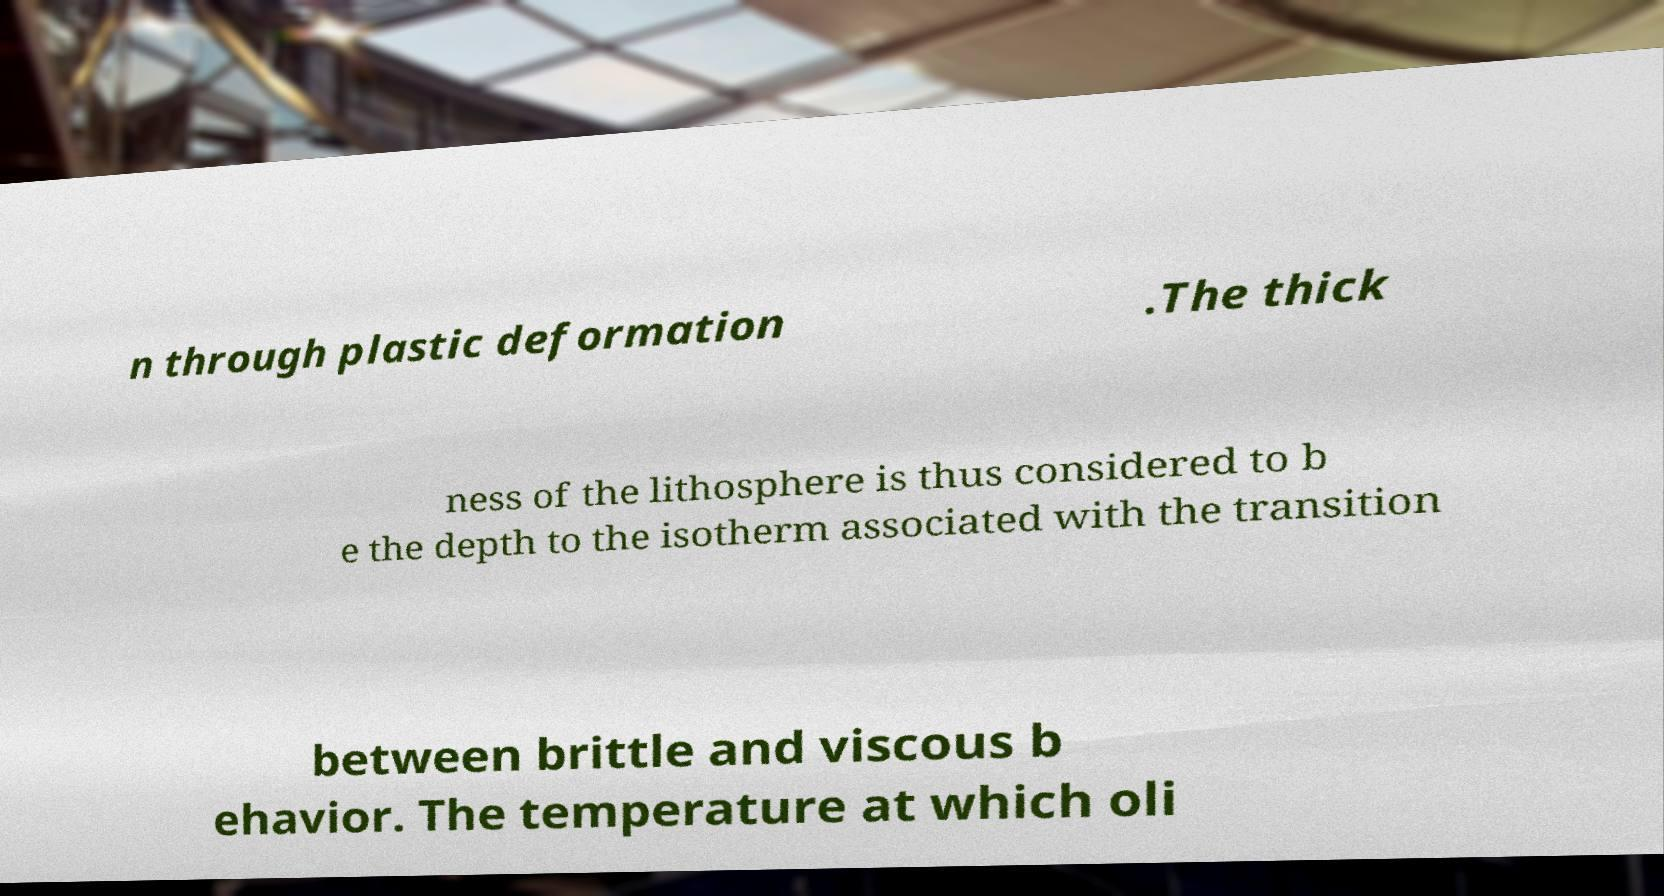Can you accurately transcribe the text from the provided image for me? n through plastic deformation .The thick ness of the lithosphere is thus considered to b e the depth to the isotherm associated with the transition between brittle and viscous b ehavior. The temperature at which oli 